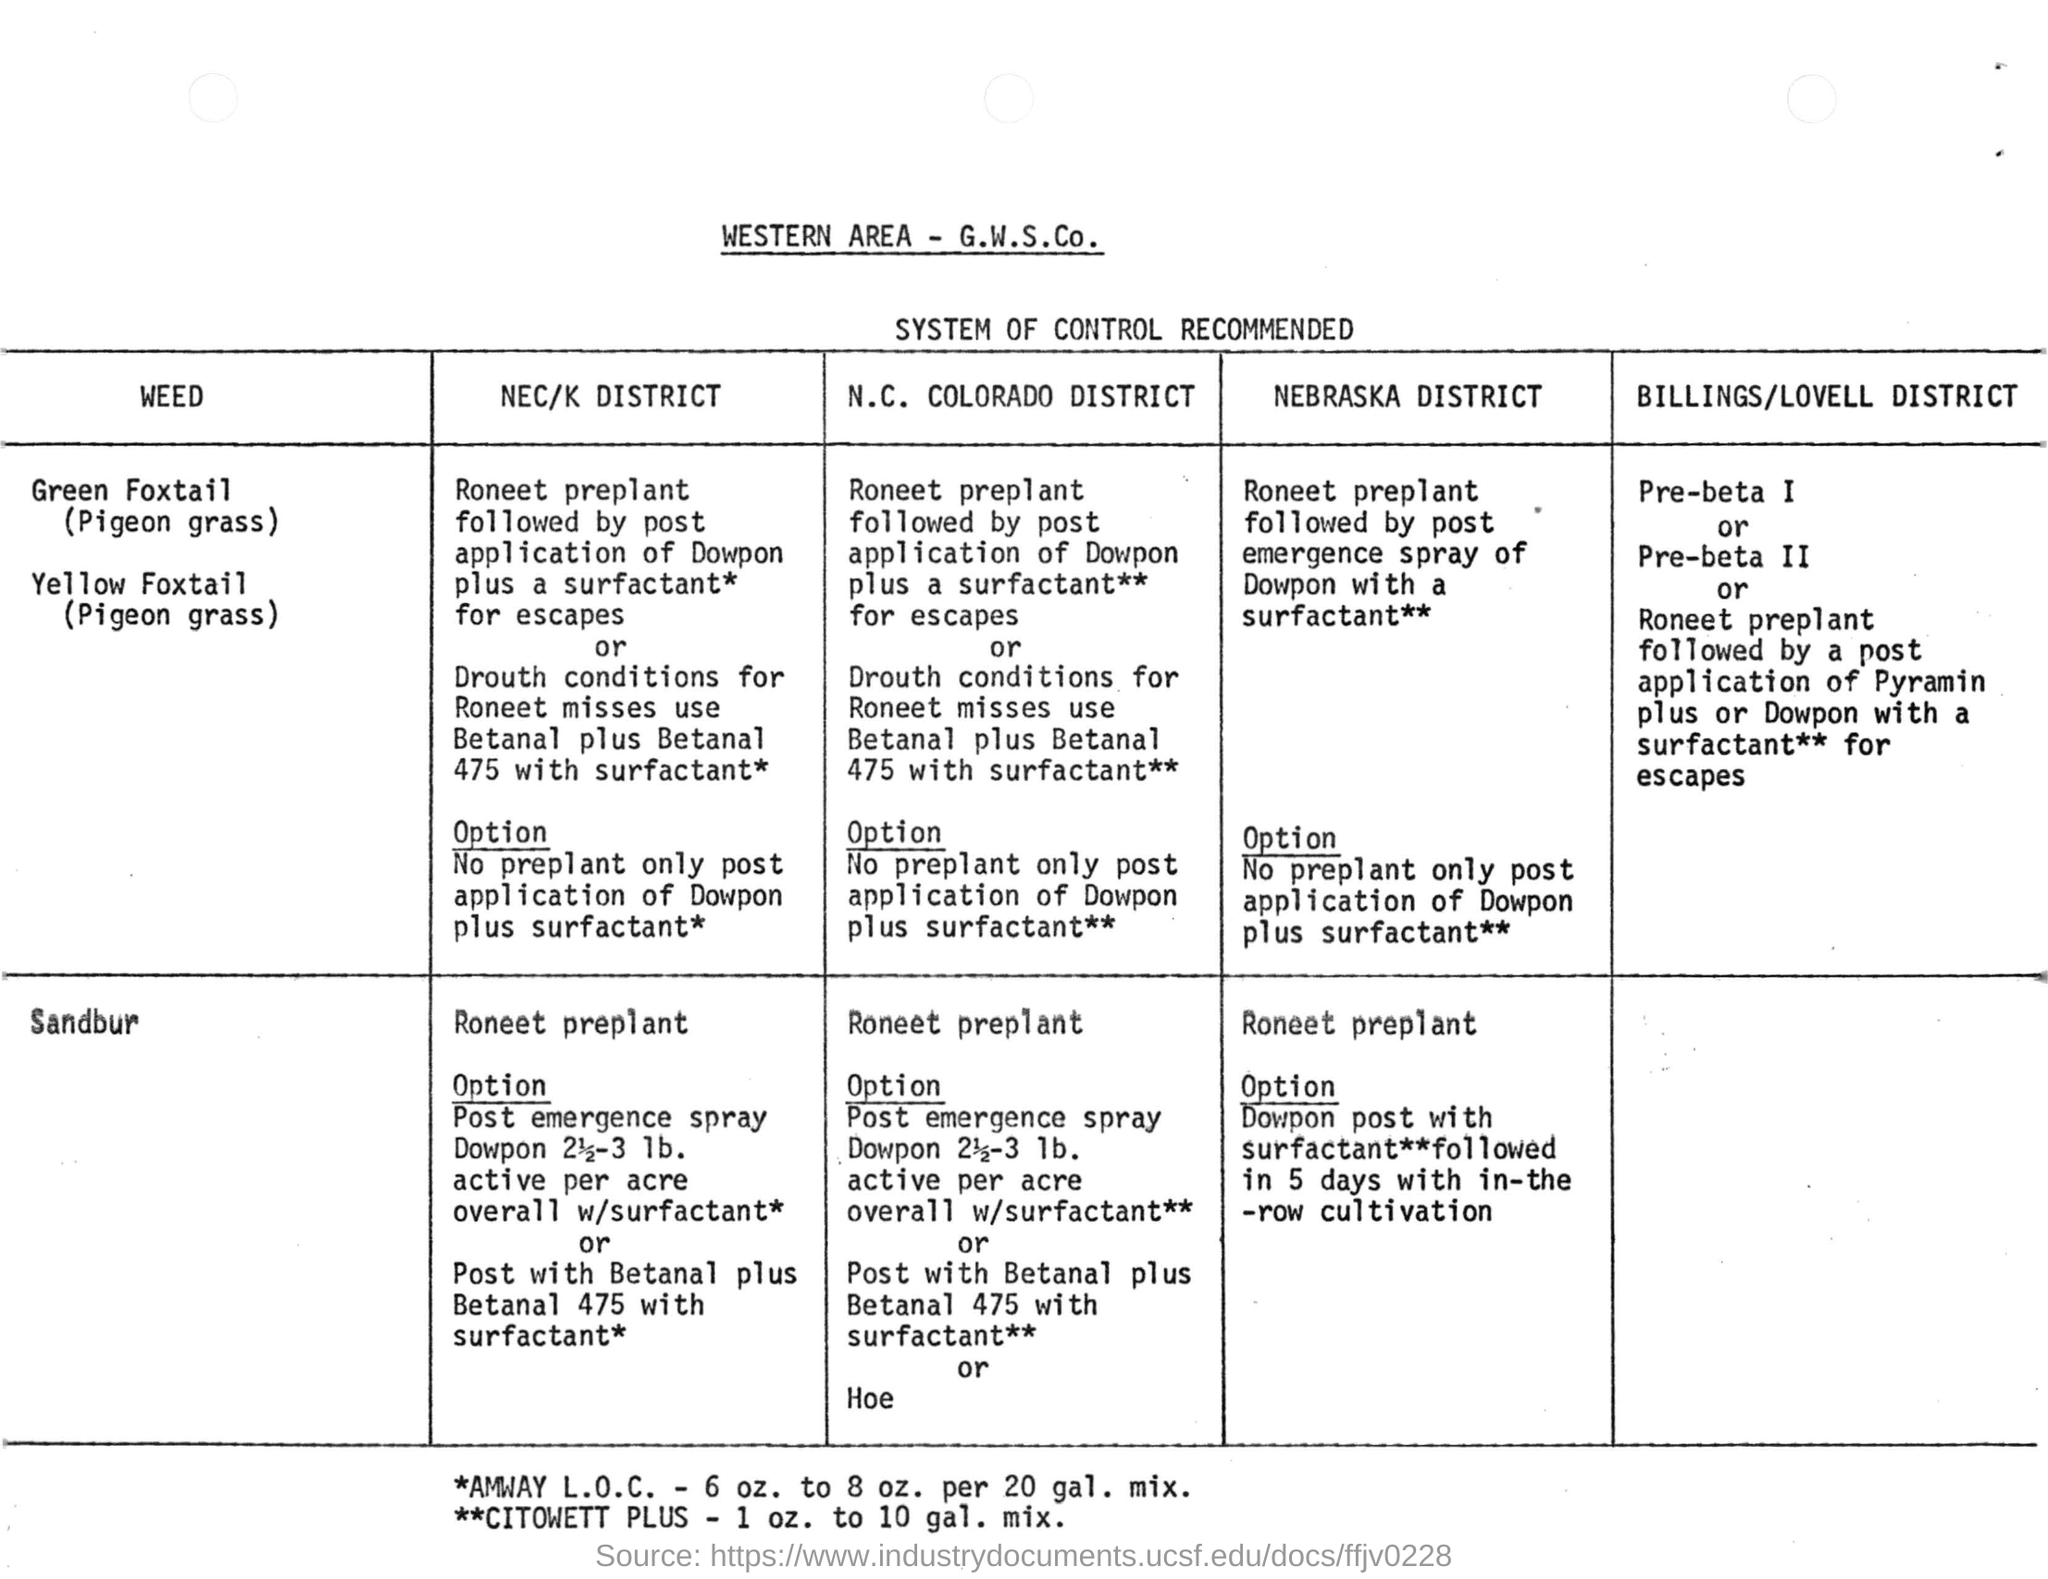What is the heading of the document?
Your response must be concise. WESTERN AREA - G.W.S.Co. What is the heading of the table?
Make the answer very short. SYSTEM OF CONTROL RECOMMENDED. What did the first asterisk(*) mean?
Keep it short and to the point. AMWAY L.O.C. - 6 OZ. TO 8 OZ. PER 20 GAL. MIX. 